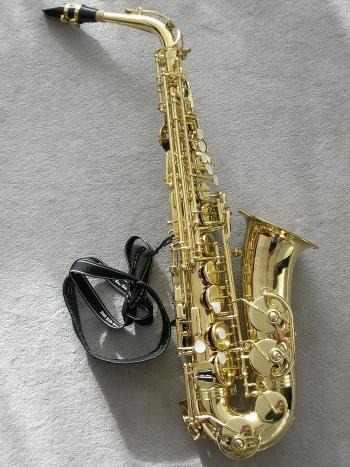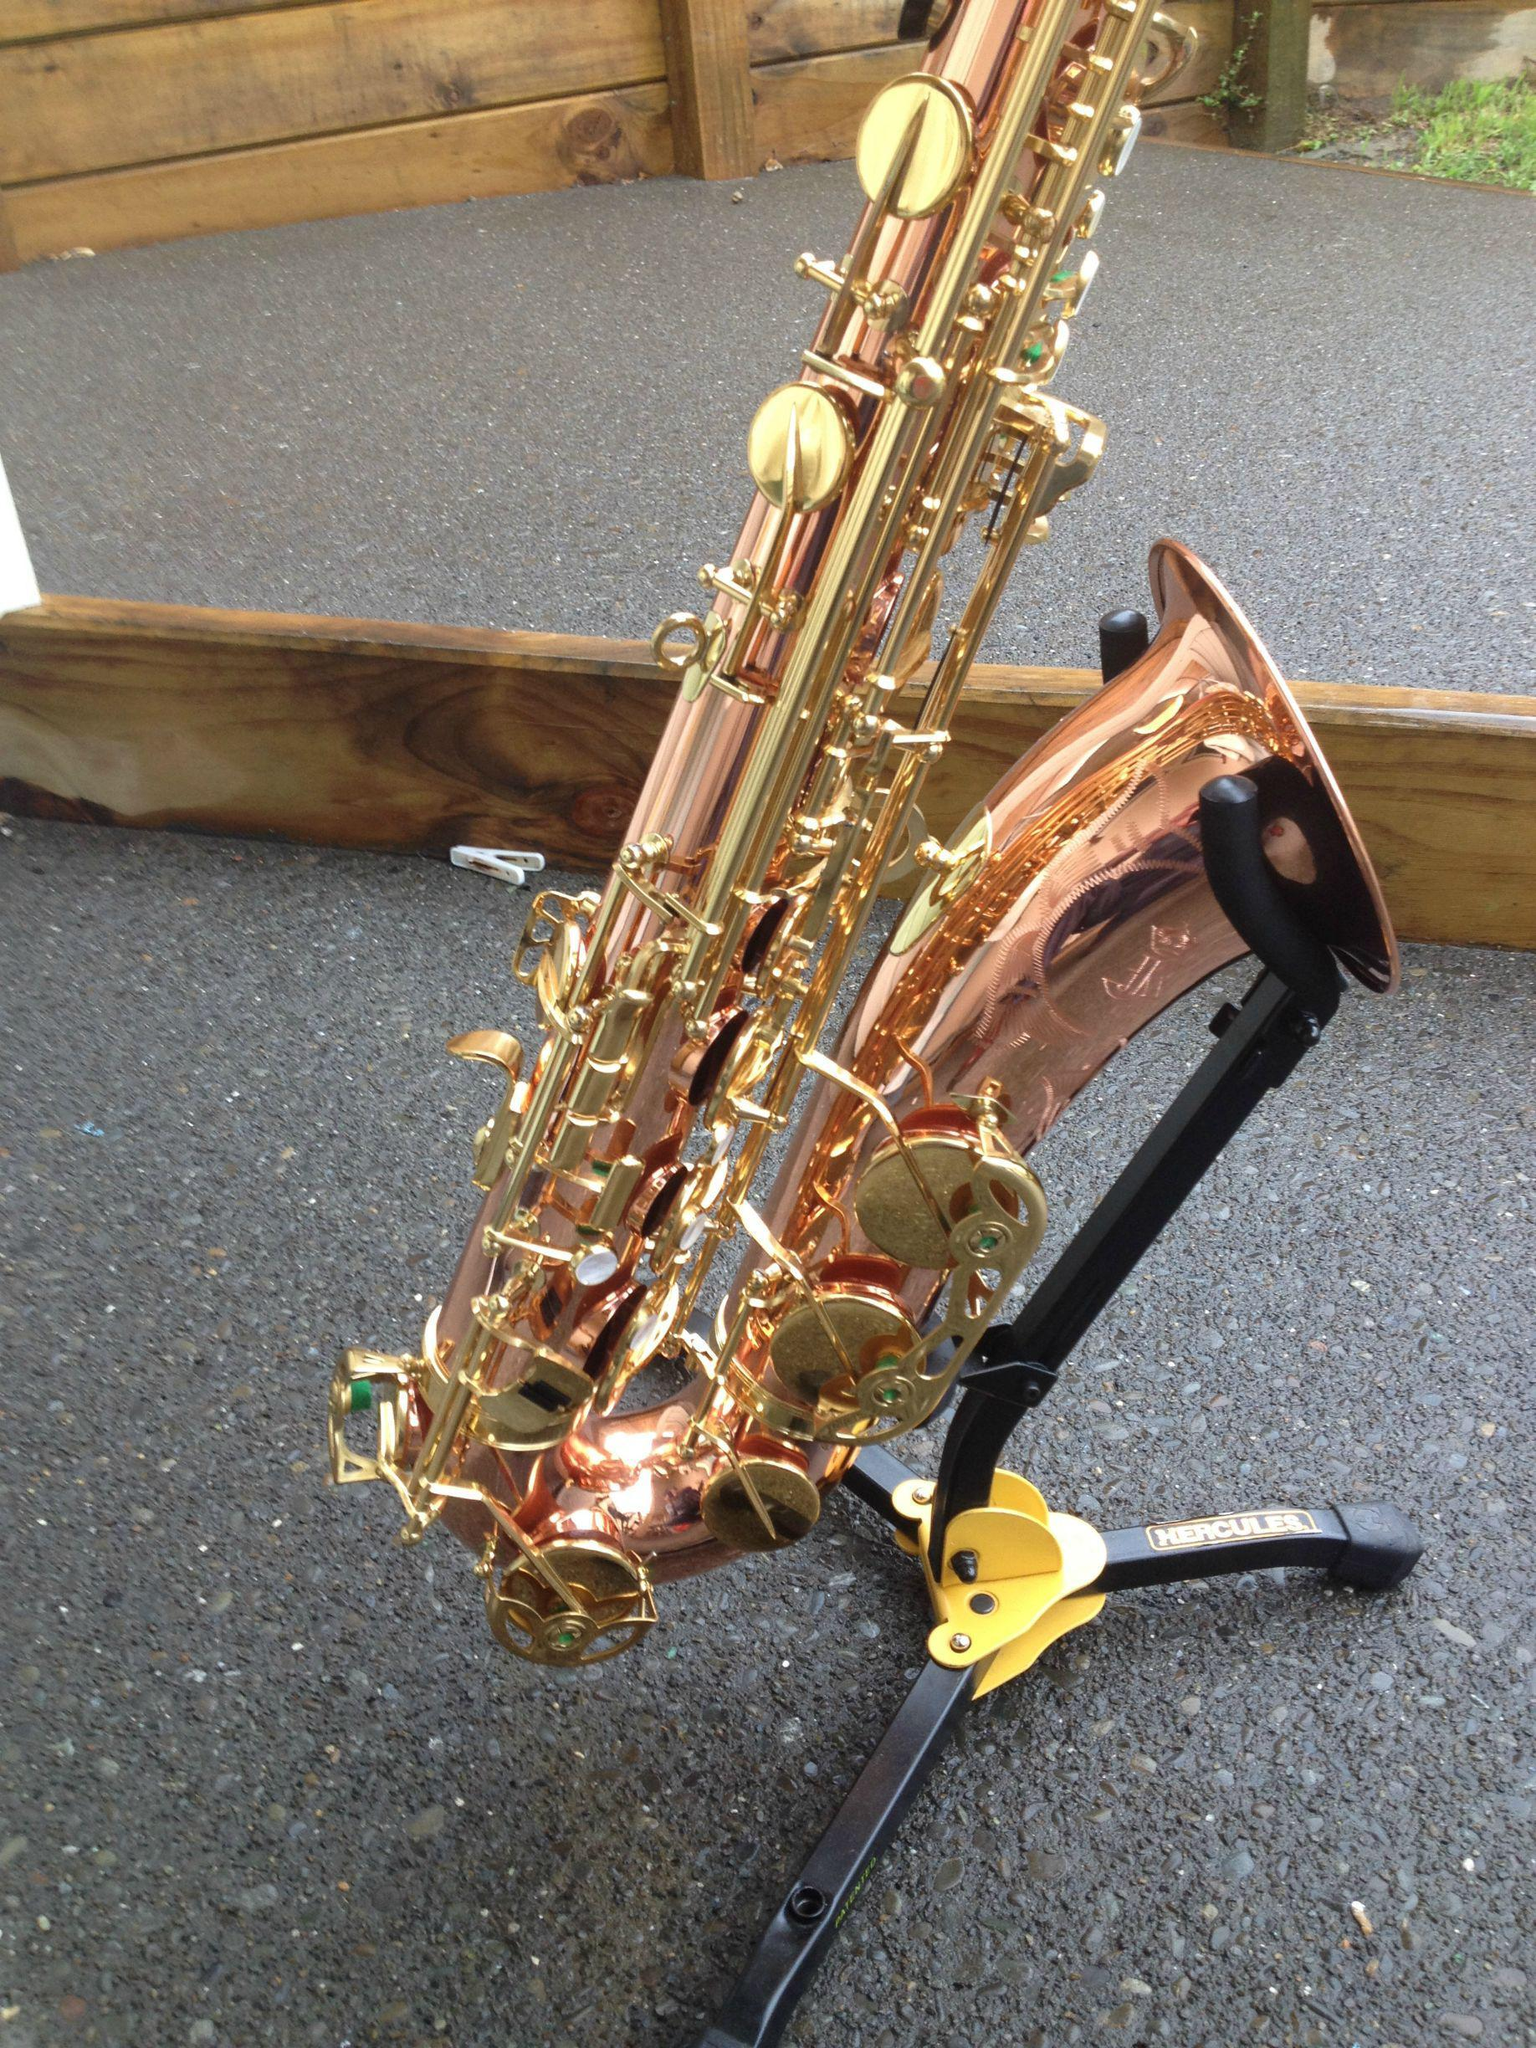The first image is the image on the left, the second image is the image on the right. Considering the images on both sides, is "An image includes a saxophone displayed on a black stand." valid? Answer yes or no. Yes. The first image is the image on the left, the second image is the image on the right. For the images shown, is this caption "Both saxes are being positioned to face the same way." true? Answer yes or no. Yes. 